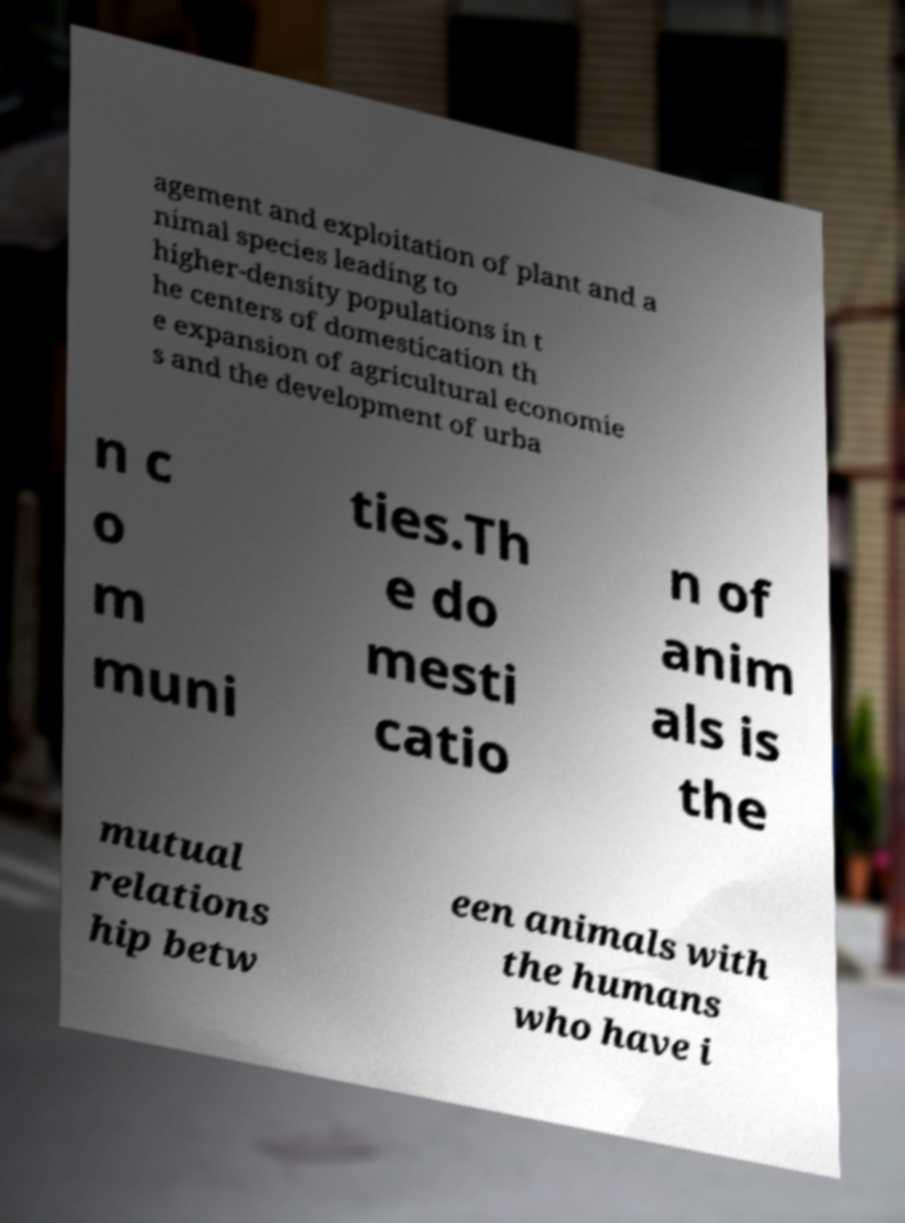There's text embedded in this image that I need extracted. Can you transcribe it verbatim? agement and exploitation of plant and a nimal species leading to higher-density populations in t he centers of domestication th e expansion of agricultural economie s and the development of urba n c o m muni ties.Th e do mesti catio n of anim als is the mutual relations hip betw een animals with the humans who have i 